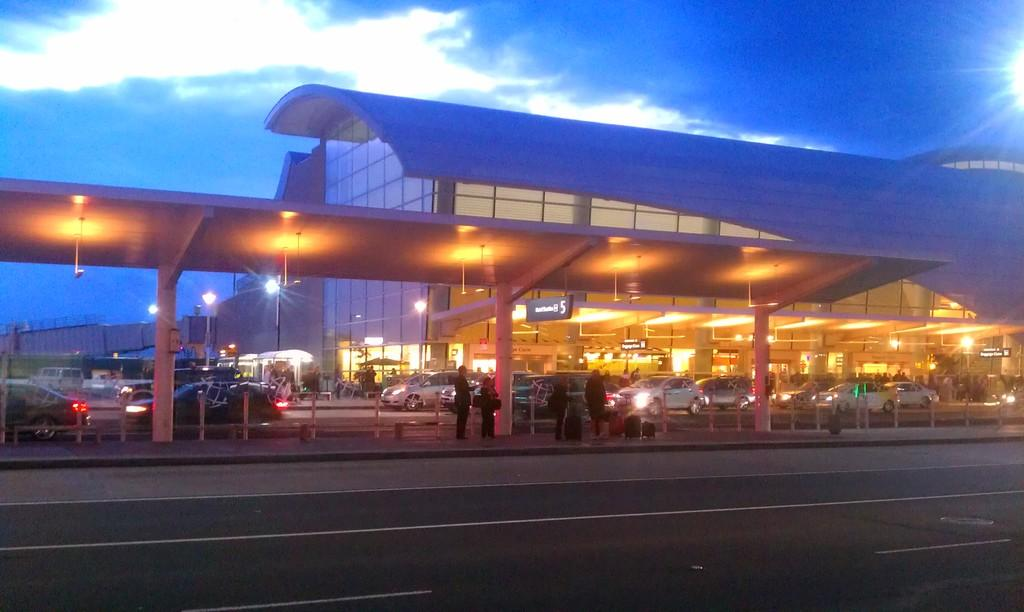What is in the foreground of the image? There is a road in the foreground of the image. What else can be seen in the image besides the road? There are people and vehicles in the image. Can you describe the lighting conditions in the image? There is light visible in the image. What is visible in the background of the image? There are buildings and the sky in the background of the image. Can you hear the duck laughing in the image? There is no duck present in the image, and therefore no sound or laughter can be heard. 